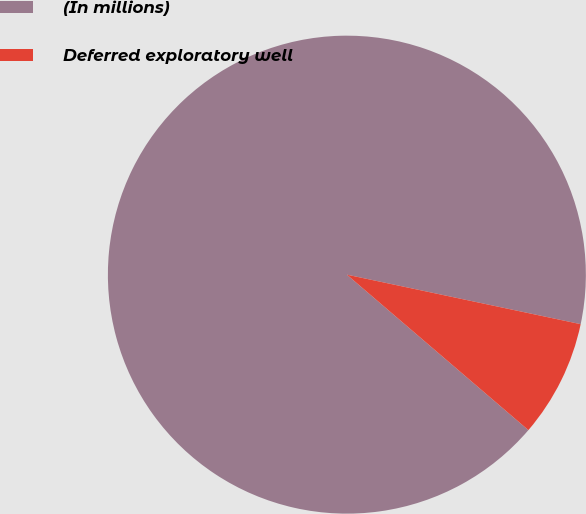Convert chart. <chart><loc_0><loc_0><loc_500><loc_500><pie_chart><fcel>(In millions)<fcel>Deferred exploratory well<nl><fcel>92.05%<fcel>7.95%<nl></chart> 